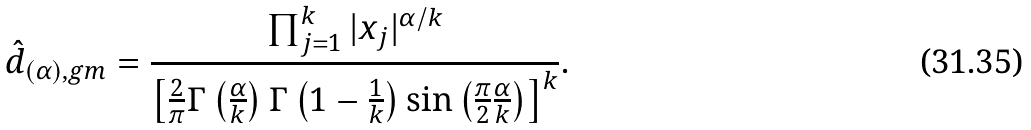<formula> <loc_0><loc_0><loc_500><loc_500>\hat { d } _ { ( \alpha ) , g m } & = \frac { \prod _ { j = 1 } ^ { k } | x _ { j } | ^ { \alpha / k } } { \left [ \frac { 2 } { \pi } \Gamma \left ( \frac { \alpha } { k } \right ) \Gamma \left ( 1 - \frac { 1 } { k } \right ) \sin \left ( \frac { \pi } { 2 } \frac { \alpha } { k } \right ) \right ] ^ { k } } .</formula> 